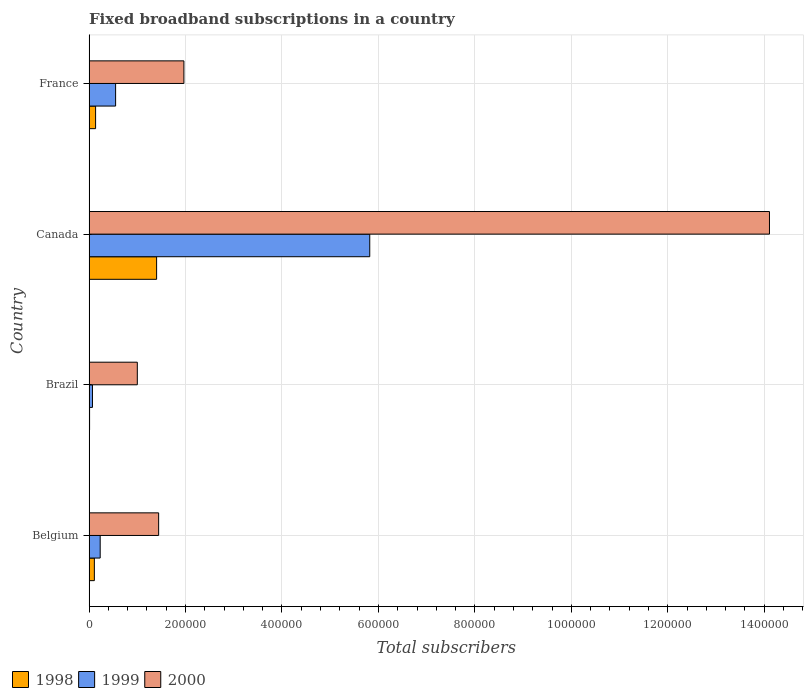How many bars are there on the 1st tick from the top?
Offer a terse response. 3. What is the number of broadband subscriptions in 1999 in France?
Your answer should be very brief. 5.50e+04. Across all countries, what is the maximum number of broadband subscriptions in 2000?
Offer a very short reply. 1.41e+06. Across all countries, what is the minimum number of broadband subscriptions in 1998?
Keep it short and to the point. 1000. In which country was the number of broadband subscriptions in 1999 maximum?
Give a very brief answer. Canada. In which country was the number of broadband subscriptions in 1998 minimum?
Give a very brief answer. Brazil. What is the total number of broadband subscriptions in 2000 in the graph?
Your response must be concise. 1.85e+06. What is the difference between the number of broadband subscriptions in 1998 in Canada and that in France?
Your response must be concise. 1.27e+05. What is the difference between the number of broadband subscriptions in 2000 in Brazil and the number of broadband subscriptions in 1999 in Belgium?
Your answer should be compact. 7.70e+04. What is the average number of broadband subscriptions in 2000 per country?
Your answer should be very brief. 4.63e+05. What is the difference between the number of broadband subscriptions in 1998 and number of broadband subscriptions in 1999 in Brazil?
Offer a terse response. -6000. What is the ratio of the number of broadband subscriptions in 1999 in Brazil to that in France?
Offer a very short reply. 0.13. Is the number of broadband subscriptions in 2000 in Brazil less than that in France?
Your response must be concise. Yes. What is the difference between the highest and the second highest number of broadband subscriptions in 2000?
Ensure brevity in your answer.  1.21e+06. What is the difference between the highest and the lowest number of broadband subscriptions in 1998?
Your answer should be compact. 1.39e+05. What does the 3rd bar from the top in France represents?
Your answer should be compact. 1998. What does the 1st bar from the bottom in Brazil represents?
Ensure brevity in your answer.  1998. Is it the case that in every country, the sum of the number of broadband subscriptions in 1999 and number of broadband subscriptions in 2000 is greater than the number of broadband subscriptions in 1998?
Ensure brevity in your answer.  Yes. What is the difference between two consecutive major ticks on the X-axis?
Provide a succinct answer. 2.00e+05. Does the graph contain grids?
Your answer should be very brief. Yes. How many legend labels are there?
Offer a terse response. 3. What is the title of the graph?
Offer a very short reply. Fixed broadband subscriptions in a country. What is the label or title of the X-axis?
Your answer should be compact. Total subscribers. What is the Total subscribers in 1998 in Belgium?
Give a very brief answer. 1.09e+04. What is the Total subscribers of 1999 in Belgium?
Offer a very short reply. 2.30e+04. What is the Total subscribers in 2000 in Belgium?
Give a very brief answer. 1.44e+05. What is the Total subscribers in 1999 in Brazil?
Keep it short and to the point. 7000. What is the Total subscribers of 1999 in Canada?
Provide a short and direct response. 5.82e+05. What is the Total subscribers in 2000 in Canada?
Provide a short and direct response. 1.41e+06. What is the Total subscribers in 1998 in France?
Your response must be concise. 1.35e+04. What is the Total subscribers in 1999 in France?
Make the answer very short. 5.50e+04. What is the Total subscribers in 2000 in France?
Make the answer very short. 1.97e+05. Across all countries, what is the maximum Total subscribers in 1999?
Provide a short and direct response. 5.82e+05. Across all countries, what is the maximum Total subscribers of 2000?
Offer a terse response. 1.41e+06. Across all countries, what is the minimum Total subscribers in 1998?
Ensure brevity in your answer.  1000. Across all countries, what is the minimum Total subscribers of 1999?
Your response must be concise. 7000. What is the total Total subscribers in 1998 in the graph?
Your answer should be very brief. 1.65e+05. What is the total Total subscribers in 1999 in the graph?
Ensure brevity in your answer.  6.67e+05. What is the total Total subscribers of 2000 in the graph?
Keep it short and to the point. 1.85e+06. What is the difference between the Total subscribers of 1998 in Belgium and that in Brazil?
Offer a very short reply. 9924. What is the difference between the Total subscribers of 1999 in Belgium and that in Brazil?
Your answer should be compact. 1.60e+04. What is the difference between the Total subscribers of 2000 in Belgium and that in Brazil?
Make the answer very short. 4.42e+04. What is the difference between the Total subscribers in 1998 in Belgium and that in Canada?
Give a very brief answer. -1.29e+05. What is the difference between the Total subscribers of 1999 in Belgium and that in Canada?
Keep it short and to the point. -5.59e+05. What is the difference between the Total subscribers of 2000 in Belgium and that in Canada?
Provide a succinct answer. -1.27e+06. What is the difference between the Total subscribers of 1998 in Belgium and that in France?
Provide a succinct answer. -2540. What is the difference between the Total subscribers in 1999 in Belgium and that in France?
Offer a terse response. -3.20e+04. What is the difference between the Total subscribers of 2000 in Belgium and that in France?
Ensure brevity in your answer.  -5.24e+04. What is the difference between the Total subscribers in 1998 in Brazil and that in Canada?
Provide a short and direct response. -1.39e+05. What is the difference between the Total subscribers in 1999 in Brazil and that in Canada?
Your answer should be very brief. -5.75e+05. What is the difference between the Total subscribers of 2000 in Brazil and that in Canada?
Make the answer very short. -1.31e+06. What is the difference between the Total subscribers in 1998 in Brazil and that in France?
Provide a succinct answer. -1.25e+04. What is the difference between the Total subscribers in 1999 in Brazil and that in France?
Your answer should be very brief. -4.80e+04. What is the difference between the Total subscribers of 2000 in Brazil and that in France?
Make the answer very short. -9.66e+04. What is the difference between the Total subscribers in 1998 in Canada and that in France?
Provide a succinct answer. 1.27e+05. What is the difference between the Total subscribers in 1999 in Canada and that in France?
Your response must be concise. 5.27e+05. What is the difference between the Total subscribers of 2000 in Canada and that in France?
Your answer should be very brief. 1.21e+06. What is the difference between the Total subscribers in 1998 in Belgium and the Total subscribers in 1999 in Brazil?
Offer a terse response. 3924. What is the difference between the Total subscribers of 1998 in Belgium and the Total subscribers of 2000 in Brazil?
Your response must be concise. -8.91e+04. What is the difference between the Total subscribers in 1999 in Belgium and the Total subscribers in 2000 in Brazil?
Offer a very short reply. -7.70e+04. What is the difference between the Total subscribers of 1998 in Belgium and the Total subscribers of 1999 in Canada?
Make the answer very short. -5.71e+05. What is the difference between the Total subscribers of 1998 in Belgium and the Total subscribers of 2000 in Canada?
Provide a succinct answer. -1.40e+06. What is the difference between the Total subscribers in 1999 in Belgium and the Total subscribers in 2000 in Canada?
Provide a succinct answer. -1.39e+06. What is the difference between the Total subscribers of 1998 in Belgium and the Total subscribers of 1999 in France?
Give a very brief answer. -4.41e+04. What is the difference between the Total subscribers in 1998 in Belgium and the Total subscribers in 2000 in France?
Offer a very short reply. -1.86e+05. What is the difference between the Total subscribers of 1999 in Belgium and the Total subscribers of 2000 in France?
Offer a terse response. -1.74e+05. What is the difference between the Total subscribers of 1998 in Brazil and the Total subscribers of 1999 in Canada?
Provide a succinct answer. -5.81e+05. What is the difference between the Total subscribers in 1998 in Brazil and the Total subscribers in 2000 in Canada?
Your answer should be compact. -1.41e+06. What is the difference between the Total subscribers of 1999 in Brazil and the Total subscribers of 2000 in Canada?
Give a very brief answer. -1.40e+06. What is the difference between the Total subscribers in 1998 in Brazil and the Total subscribers in 1999 in France?
Keep it short and to the point. -5.40e+04. What is the difference between the Total subscribers of 1998 in Brazil and the Total subscribers of 2000 in France?
Ensure brevity in your answer.  -1.96e+05. What is the difference between the Total subscribers in 1999 in Brazil and the Total subscribers in 2000 in France?
Provide a short and direct response. -1.90e+05. What is the difference between the Total subscribers of 1998 in Canada and the Total subscribers of 1999 in France?
Your answer should be very brief. 8.50e+04. What is the difference between the Total subscribers of 1998 in Canada and the Total subscribers of 2000 in France?
Offer a terse response. -5.66e+04. What is the difference between the Total subscribers of 1999 in Canada and the Total subscribers of 2000 in France?
Make the answer very short. 3.85e+05. What is the average Total subscribers of 1998 per country?
Your response must be concise. 4.13e+04. What is the average Total subscribers of 1999 per country?
Provide a short and direct response. 1.67e+05. What is the average Total subscribers of 2000 per country?
Provide a succinct answer. 4.63e+05. What is the difference between the Total subscribers in 1998 and Total subscribers in 1999 in Belgium?
Your answer should be very brief. -1.21e+04. What is the difference between the Total subscribers of 1998 and Total subscribers of 2000 in Belgium?
Keep it short and to the point. -1.33e+05. What is the difference between the Total subscribers of 1999 and Total subscribers of 2000 in Belgium?
Provide a succinct answer. -1.21e+05. What is the difference between the Total subscribers in 1998 and Total subscribers in 1999 in Brazil?
Your answer should be compact. -6000. What is the difference between the Total subscribers in 1998 and Total subscribers in 2000 in Brazil?
Offer a terse response. -9.90e+04. What is the difference between the Total subscribers in 1999 and Total subscribers in 2000 in Brazil?
Ensure brevity in your answer.  -9.30e+04. What is the difference between the Total subscribers in 1998 and Total subscribers in 1999 in Canada?
Your answer should be compact. -4.42e+05. What is the difference between the Total subscribers of 1998 and Total subscribers of 2000 in Canada?
Give a very brief answer. -1.27e+06. What is the difference between the Total subscribers of 1999 and Total subscribers of 2000 in Canada?
Your response must be concise. -8.29e+05. What is the difference between the Total subscribers of 1998 and Total subscribers of 1999 in France?
Ensure brevity in your answer.  -4.15e+04. What is the difference between the Total subscribers in 1998 and Total subscribers in 2000 in France?
Ensure brevity in your answer.  -1.83e+05. What is the difference between the Total subscribers of 1999 and Total subscribers of 2000 in France?
Your response must be concise. -1.42e+05. What is the ratio of the Total subscribers in 1998 in Belgium to that in Brazil?
Provide a short and direct response. 10.92. What is the ratio of the Total subscribers in 1999 in Belgium to that in Brazil?
Provide a short and direct response. 3.29. What is the ratio of the Total subscribers in 2000 in Belgium to that in Brazil?
Your response must be concise. 1.44. What is the ratio of the Total subscribers of 1998 in Belgium to that in Canada?
Your response must be concise. 0.08. What is the ratio of the Total subscribers in 1999 in Belgium to that in Canada?
Keep it short and to the point. 0.04. What is the ratio of the Total subscribers of 2000 in Belgium to that in Canada?
Offer a terse response. 0.1. What is the ratio of the Total subscribers in 1998 in Belgium to that in France?
Provide a succinct answer. 0.81. What is the ratio of the Total subscribers in 1999 in Belgium to that in France?
Offer a very short reply. 0.42. What is the ratio of the Total subscribers in 2000 in Belgium to that in France?
Keep it short and to the point. 0.73. What is the ratio of the Total subscribers of 1998 in Brazil to that in Canada?
Make the answer very short. 0.01. What is the ratio of the Total subscribers in 1999 in Brazil to that in Canada?
Keep it short and to the point. 0.01. What is the ratio of the Total subscribers of 2000 in Brazil to that in Canada?
Offer a terse response. 0.07. What is the ratio of the Total subscribers of 1998 in Brazil to that in France?
Keep it short and to the point. 0.07. What is the ratio of the Total subscribers of 1999 in Brazil to that in France?
Your answer should be very brief. 0.13. What is the ratio of the Total subscribers of 2000 in Brazil to that in France?
Keep it short and to the point. 0.51. What is the ratio of the Total subscribers in 1998 in Canada to that in France?
Provide a short and direct response. 10.4. What is the ratio of the Total subscribers of 1999 in Canada to that in France?
Your answer should be very brief. 10.58. What is the ratio of the Total subscribers of 2000 in Canada to that in France?
Keep it short and to the point. 7.18. What is the difference between the highest and the second highest Total subscribers in 1998?
Ensure brevity in your answer.  1.27e+05. What is the difference between the highest and the second highest Total subscribers of 1999?
Your response must be concise. 5.27e+05. What is the difference between the highest and the second highest Total subscribers of 2000?
Offer a terse response. 1.21e+06. What is the difference between the highest and the lowest Total subscribers in 1998?
Offer a terse response. 1.39e+05. What is the difference between the highest and the lowest Total subscribers in 1999?
Keep it short and to the point. 5.75e+05. What is the difference between the highest and the lowest Total subscribers of 2000?
Ensure brevity in your answer.  1.31e+06. 